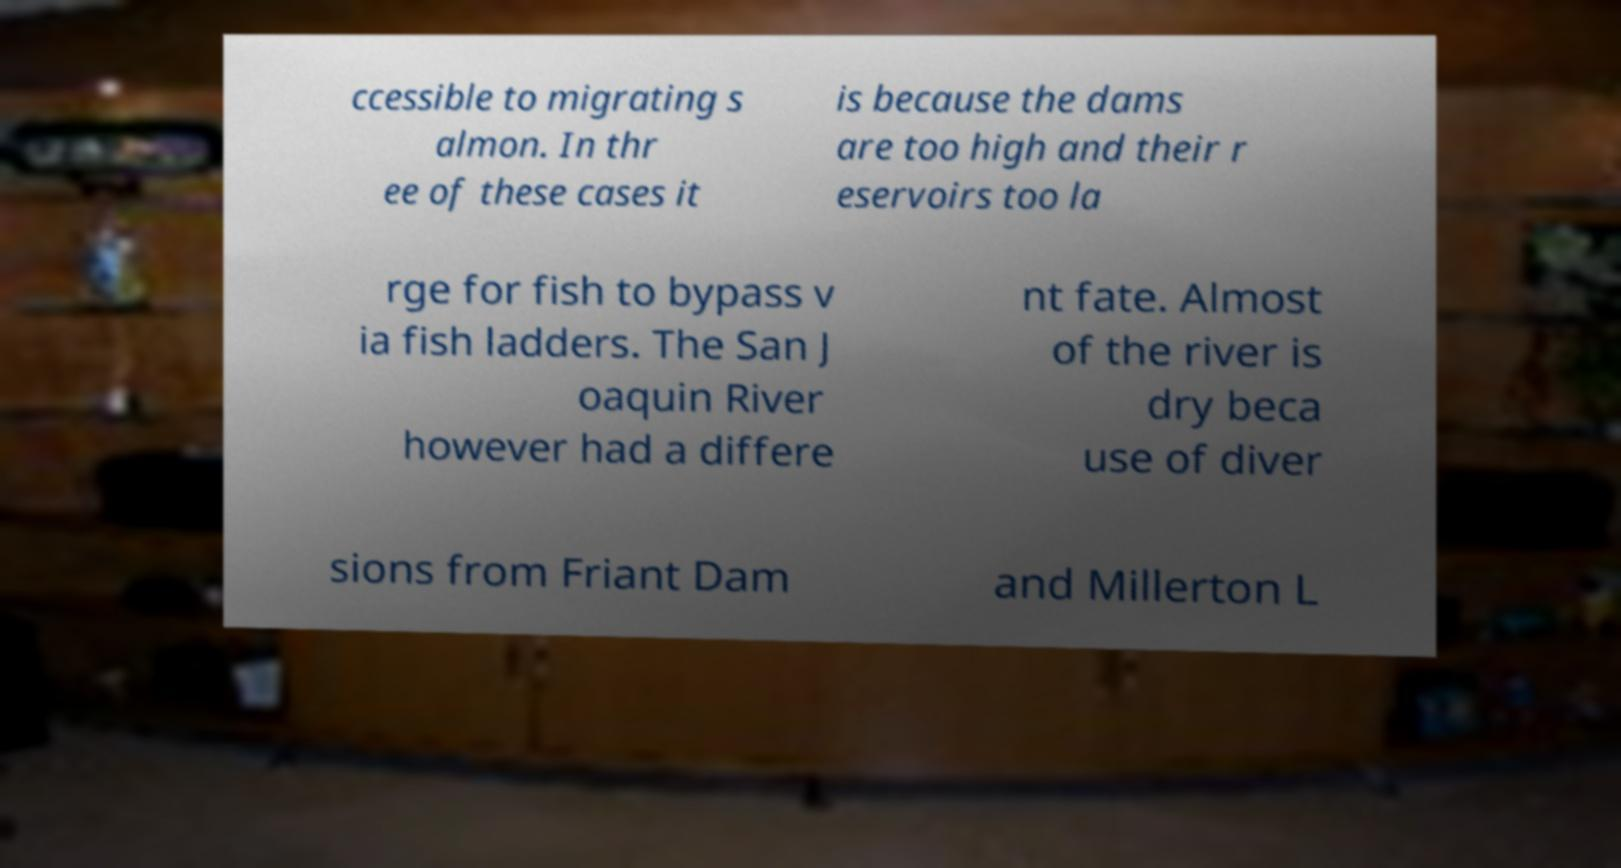What messages or text are displayed in this image? I need them in a readable, typed format. ccessible to migrating s almon. In thr ee of these cases it is because the dams are too high and their r eservoirs too la rge for fish to bypass v ia fish ladders. The San J oaquin River however had a differe nt fate. Almost of the river is dry beca use of diver sions from Friant Dam and Millerton L 